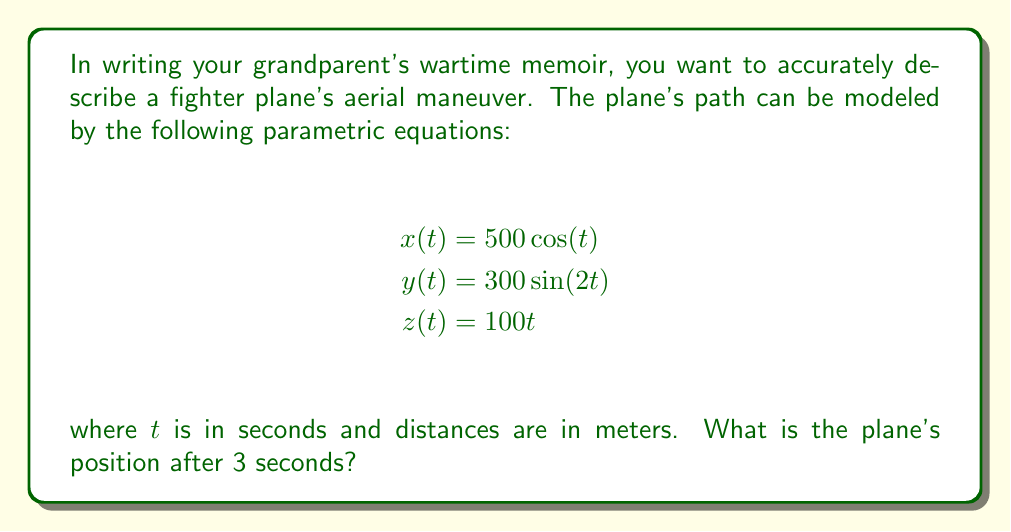Solve this math problem. To find the plane's position after 3 seconds, we need to evaluate the parametric equations at $t = 3$. Let's calculate each coordinate separately:

1. For the x-coordinate:
   $$x(3) = 500\cos(3)$$
   Using a calculator or approximation, we get:
   $$x(3) \approx -499.62\text{ meters}$$

2. For the y-coordinate:
   $$y(3) = 300\sin(2(3)) = 300\sin(6)$$
   $$y(3) \approx -13.05\text{ meters}$$

3. For the z-coordinate:
   $$z(3) = 100(3) = 300\text{ meters}$$

Therefore, after 3 seconds, the plane's position will be approximately (-499.62, -13.05, 300) meters.

This path represents a complex aerial maneuver:
- The x-coordinate follows a cosine function, creating a horizontal oscillation.
- The y-coordinate follows a sine function with double the frequency, creating a vertical figure-eight pattern.
- The z-coordinate increases linearly with time, indicating a steady climb.

This combination results in a spiraling climb with a figure-eight cross-section, which could represent an advanced evasive or acrobatic maneuver performed by a skilled fighter pilot.
Answer: (-499.62, -13.05, 300) meters 